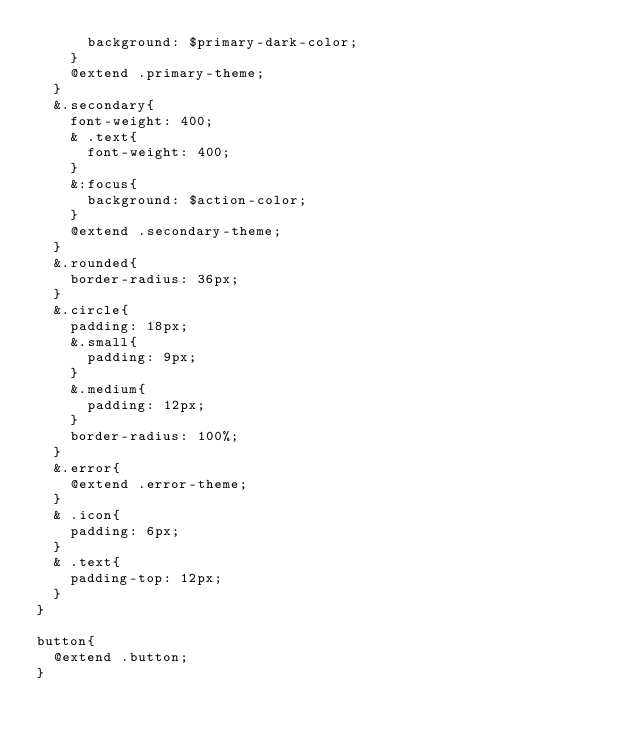Convert code to text. <code><loc_0><loc_0><loc_500><loc_500><_CSS_>      background: $primary-dark-color; 
    }
    @extend .primary-theme;
  }
  &.secondary{
    font-weight: 400;
    & .text{
      font-weight: 400;
    }
    &:focus{
      background: $action-color; 
    }
    @extend .secondary-theme;
  }
  &.rounded{
    border-radius: 36px;
  }
  &.circle{
    padding: 18px;
    &.small{
      padding: 9px;
    }
    &.medium{
      padding: 12px;
    }
    border-radius: 100%;
  }
  &.error{
    @extend .error-theme;
  }
  & .icon{
    padding: 6px;
  }
  & .text{
    padding-top: 12px;
  }
}

button{
  @extend .button;
}
</code> 